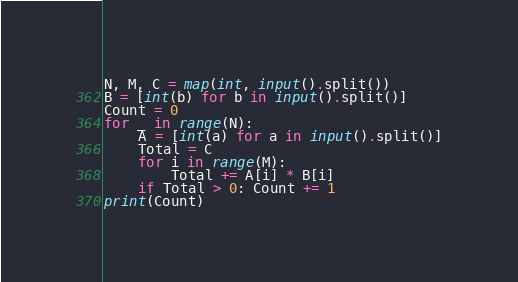<code> <loc_0><loc_0><loc_500><loc_500><_Python_>N, M, C = map(int, input().split())
B = [int(b) for b in input().split()]
Count = 0
for _ in range(N):
    A = [int(a) for a in input().split()]
    Total = C
    for i in range(M):
        Total += A[i] * B[i]
    if Total > 0: Count += 1
print(Count)
</code> 